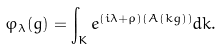<formula> <loc_0><loc_0><loc_500><loc_500>\varphi _ { \lambda } ( g ) = \int _ { K } e ^ { ( i \lambda + \rho ) ( A ( k g ) ) } d k .</formula> 